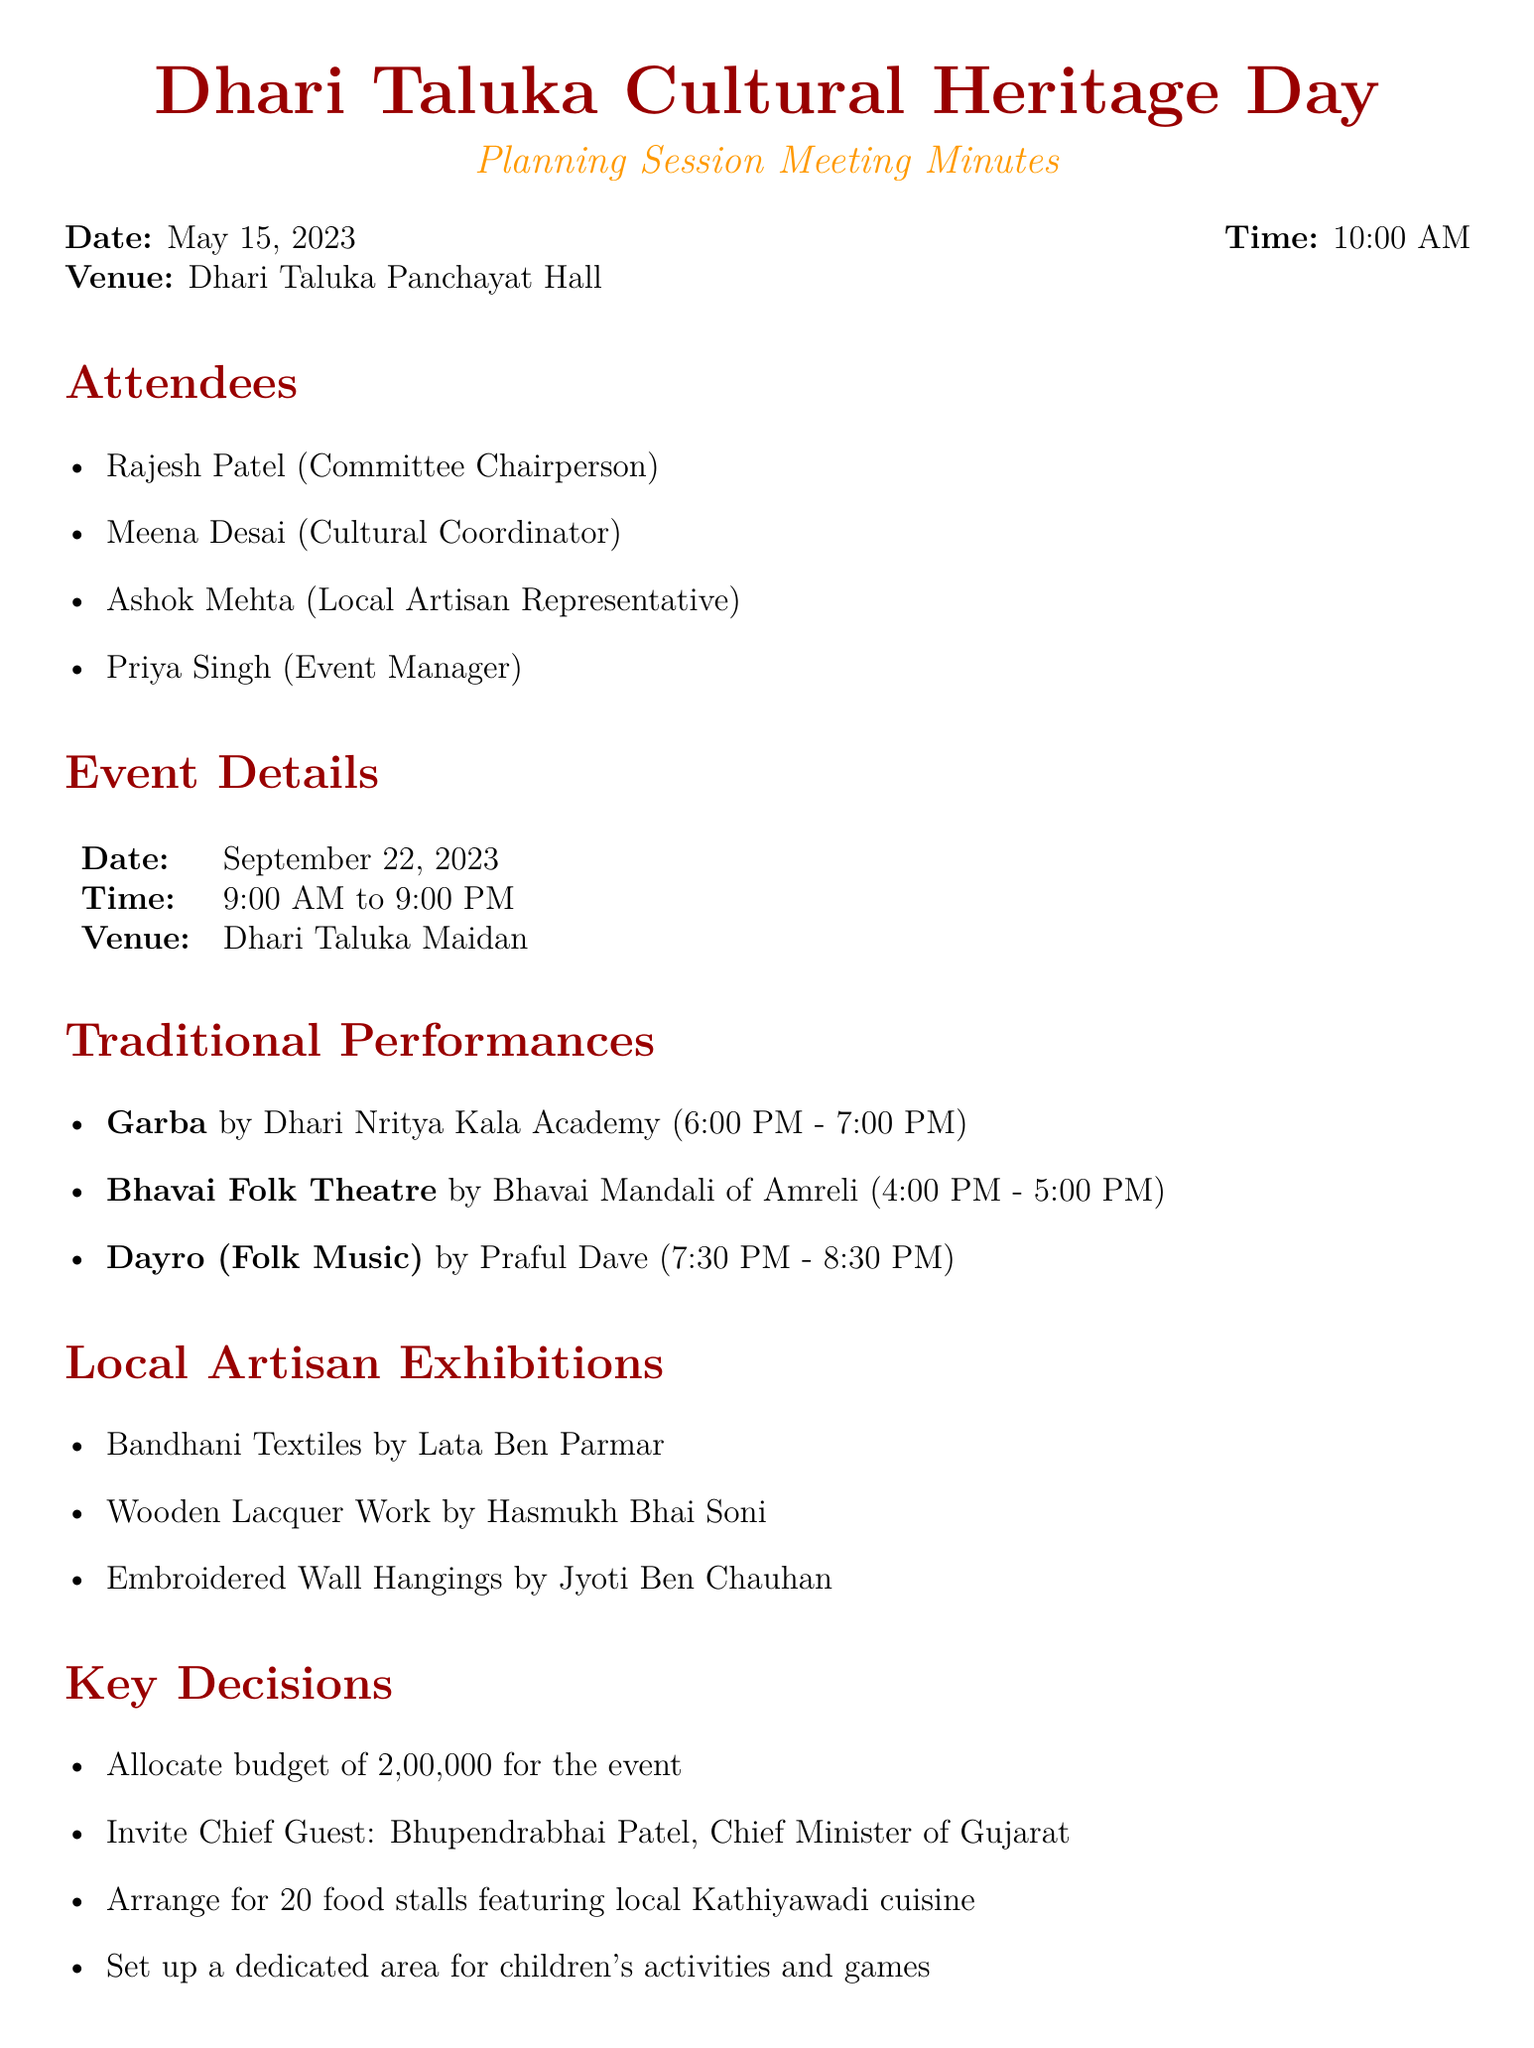What is the date of the event? The event date is specified in the document under event details.
Answer: September 22, 2023 Who is the Chief Guest invited to the event? The Chief Guest is mentioned in the key decisions section of the document.
Answer: Bhupendrabhai Patel What time does the Garba performance start? The start time for the Garba performance is listed under traditional performances.
Answer: 6:00 PM How much budget has been allocated for the event? The allocated budget is detailed in the key decisions section of the document.
Answer: ₹2,00,000 Which artisan is showcasing Wooden Lacquer Work? The artisan showcasing Wooden Lacquer Work is listed under local artisan exhibitions.
Answer: Hasmukh Bhai Soni What is the deadline for designing event posters and banners? The deadline for the task is indicated in the action items in the document.
Answer: June 15, 2023 Which venue is selected for the Cultural Heritage Day? The selected venue is found in the event details section of the document.
Answer: Dhari Taluka Maidan What activities are being arranged for children? The document mentions arrangements for children's activities in the key decisions section.
Answer: Area for children's activities and games 